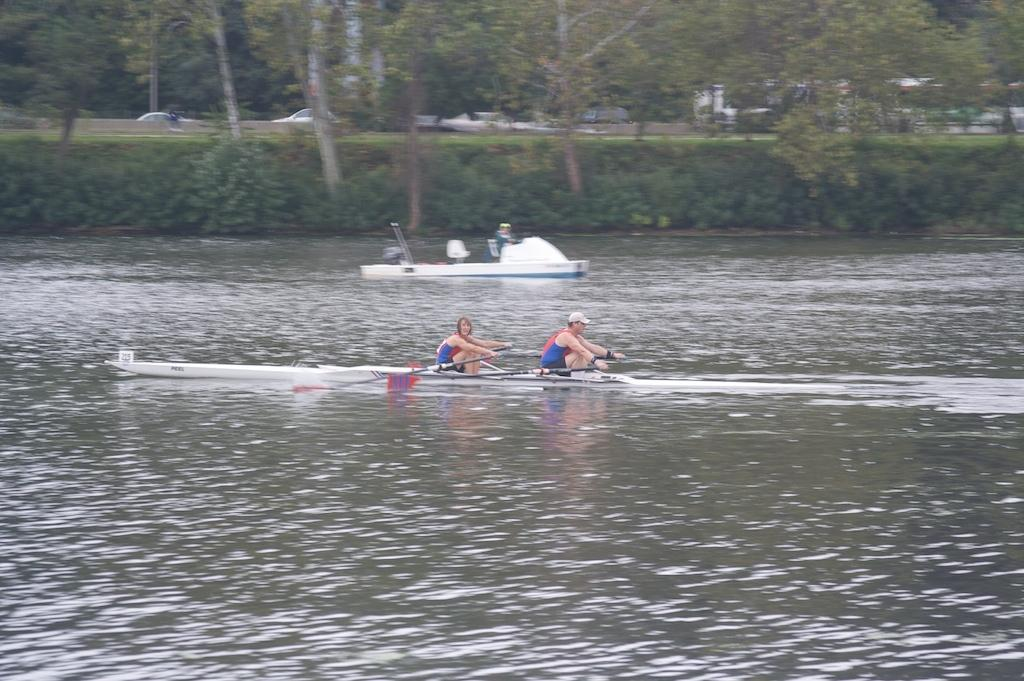What is the main subject of the image? The main subject of the image is boats. What are the boats doing in the image? The boats are sailing on the water in the image. Are there any people on the boats? Yes, there are people on the boats in the image. What can be seen in the background of the image? In the background of the image, there are trees, plants, and other objects. What type of amusement can be seen on the boats in the image? There is no amusement visible on the boats in the image; they are simply sailing on the water. What role does coal play in the image? There is no mention of coal in the image; it is not present or relevant to the scene. 